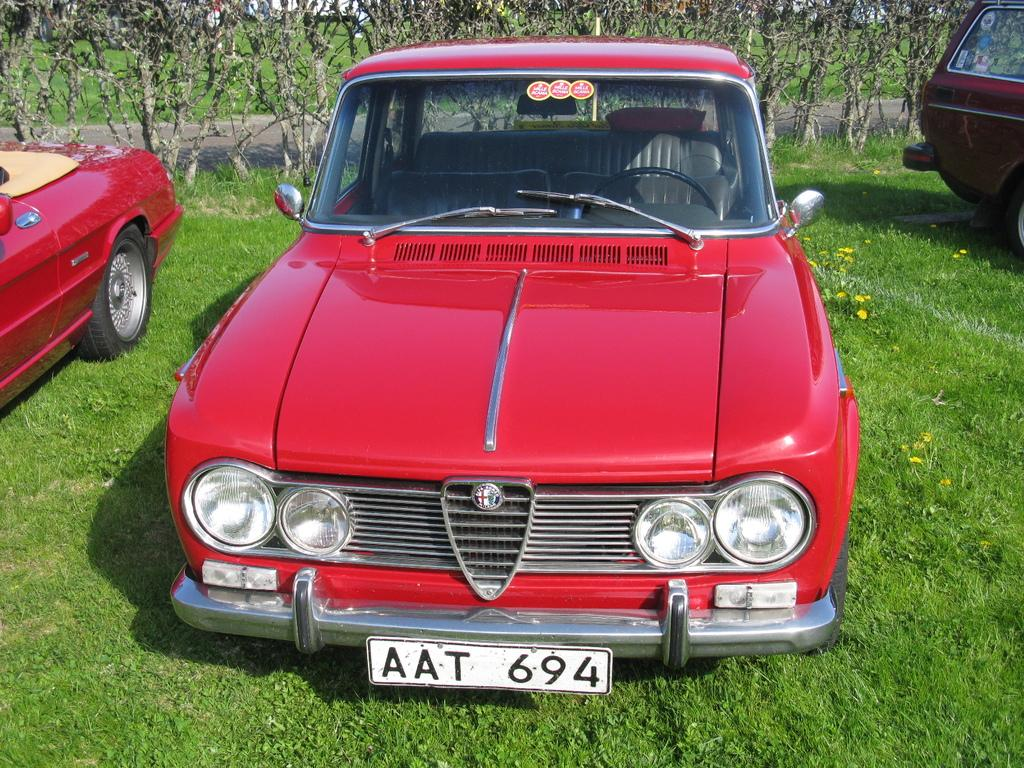What types of objects are present in the image? There are vehicles in the image. What type of natural environment is visible in the image? There is grass and plants in the image. What type of flowers can be seen in the image? There are yellow color flowers in the image. Is there any text or writing visible in the image? Yes, there is text or writing visible in the image. How many quinces are hanging from the trees in the image? There are no quinces present in the image; it features yellow flowers instead. Can you tell me where the cellar is located in the image? There is no cellar present in the image. 